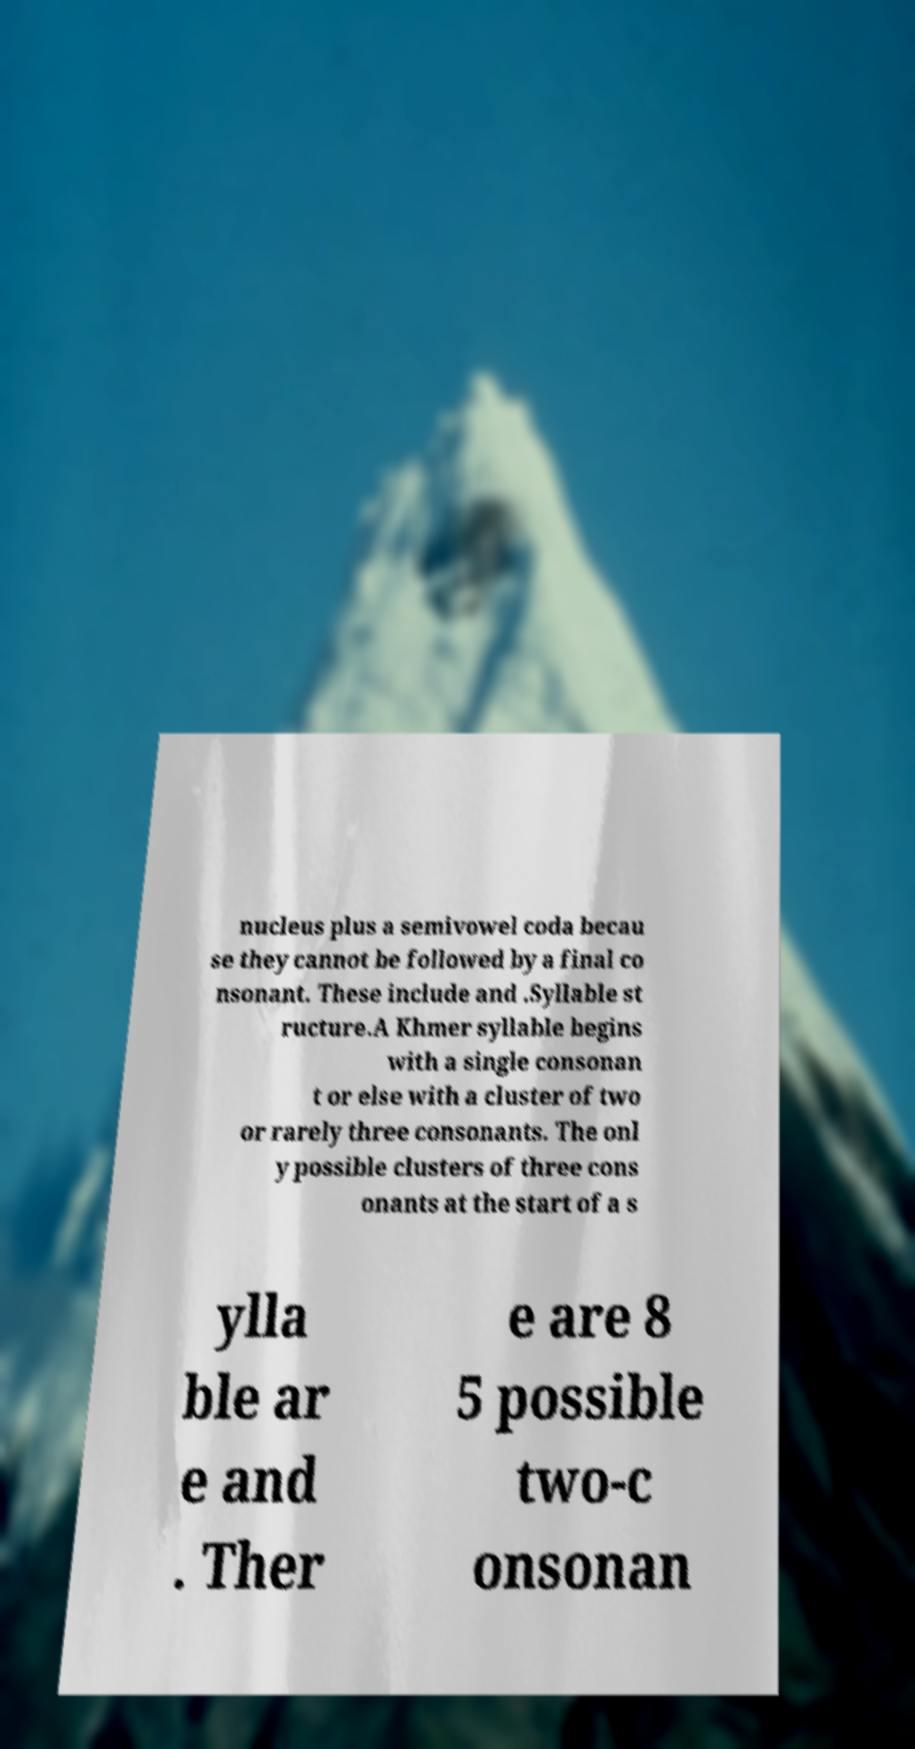Could you assist in decoding the text presented in this image and type it out clearly? nucleus plus a semivowel coda becau se they cannot be followed by a final co nsonant. These include and .Syllable st ructure.A Khmer syllable begins with a single consonan t or else with a cluster of two or rarely three consonants. The onl y possible clusters of three cons onants at the start of a s ylla ble ar e and . Ther e are 8 5 possible two-c onsonan 